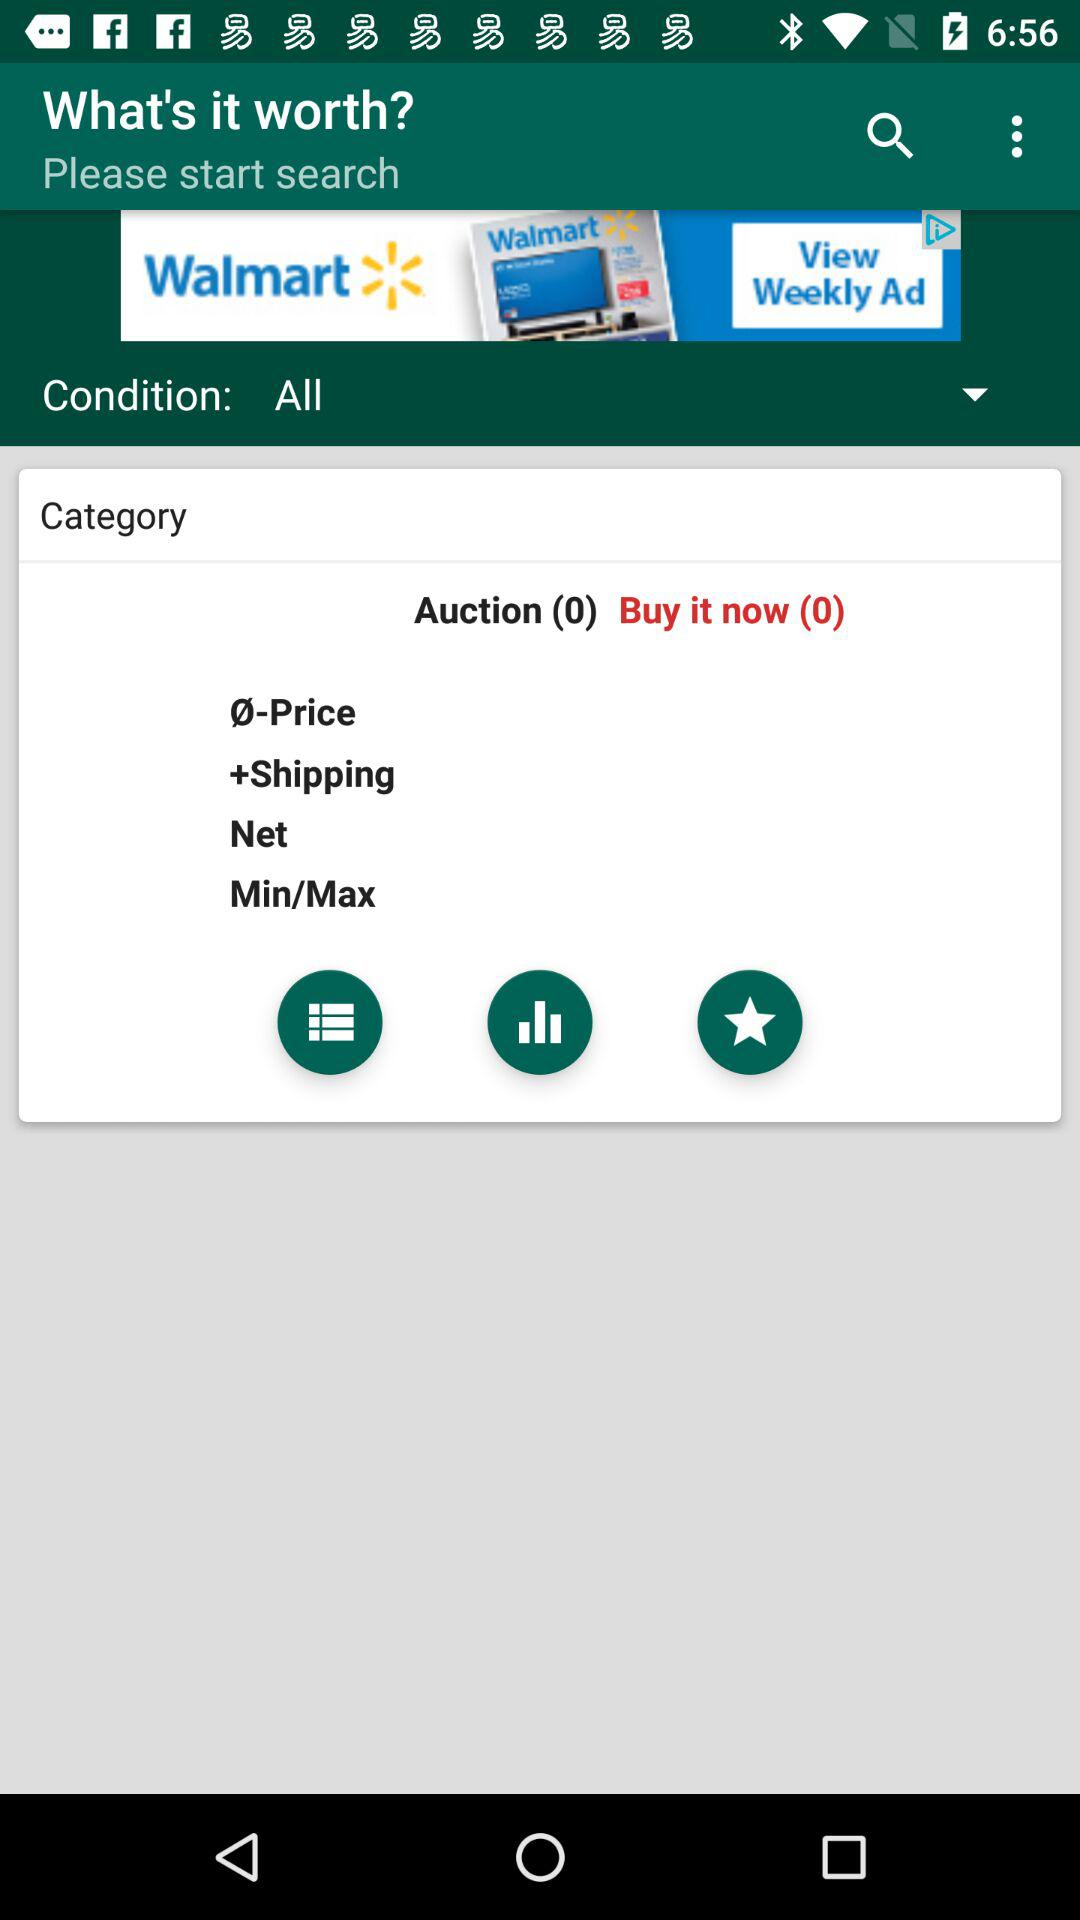What is the number in the "Buy it now"? The number in the "Buy it now" is 0. 